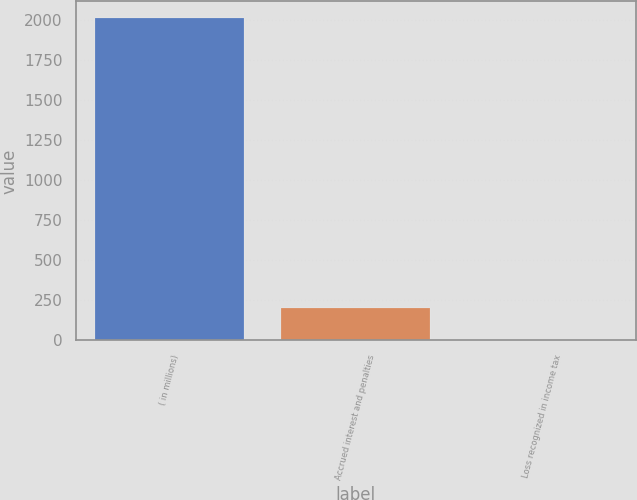Convert chart. <chart><loc_0><loc_0><loc_500><loc_500><bar_chart><fcel>( in millions)<fcel>Accrued interest and penalties<fcel>Loss recognized in income tax<nl><fcel>2018<fcel>203.6<fcel>2<nl></chart> 